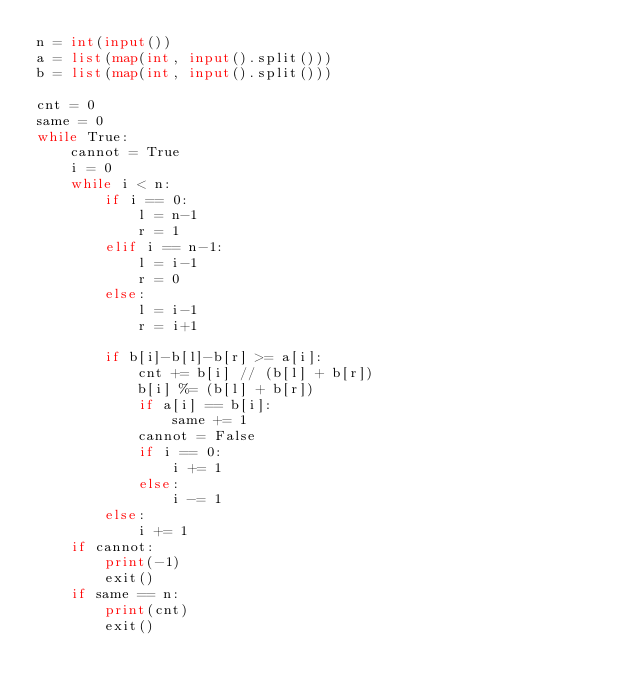<code> <loc_0><loc_0><loc_500><loc_500><_Python_>n = int(input())
a = list(map(int, input().split()))
b = list(map(int, input().split()))

cnt = 0
same = 0
while True:
    cannot = True
    i = 0
    while i < n:
        if i == 0:
            l = n-1
            r = 1
        elif i == n-1:
            l = i-1
            r = 0
        else:
            l = i-1
            r = i+1

        if b[i]-b[l]-b[r] >= a[i]:
            cnt += b[i] // (b[l] + b[r])
            b[i] %= (b[l] + b[r])
            if a[i] == b[i]:
                same += 1
            cannot = False
            if i == 0:
                i += 1
            else:
                i -= 1
        else:
            i += 1
    if cannot:
        print(-1)
        exit()
    if same == n:
        print(cnt)
        exit()</code> 